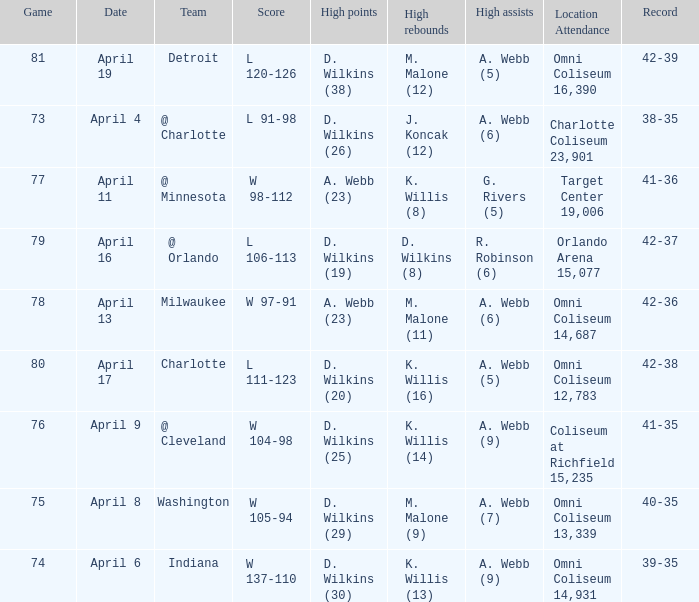How many people had the high points when a. webb (7) had the high assists? 1.0. 